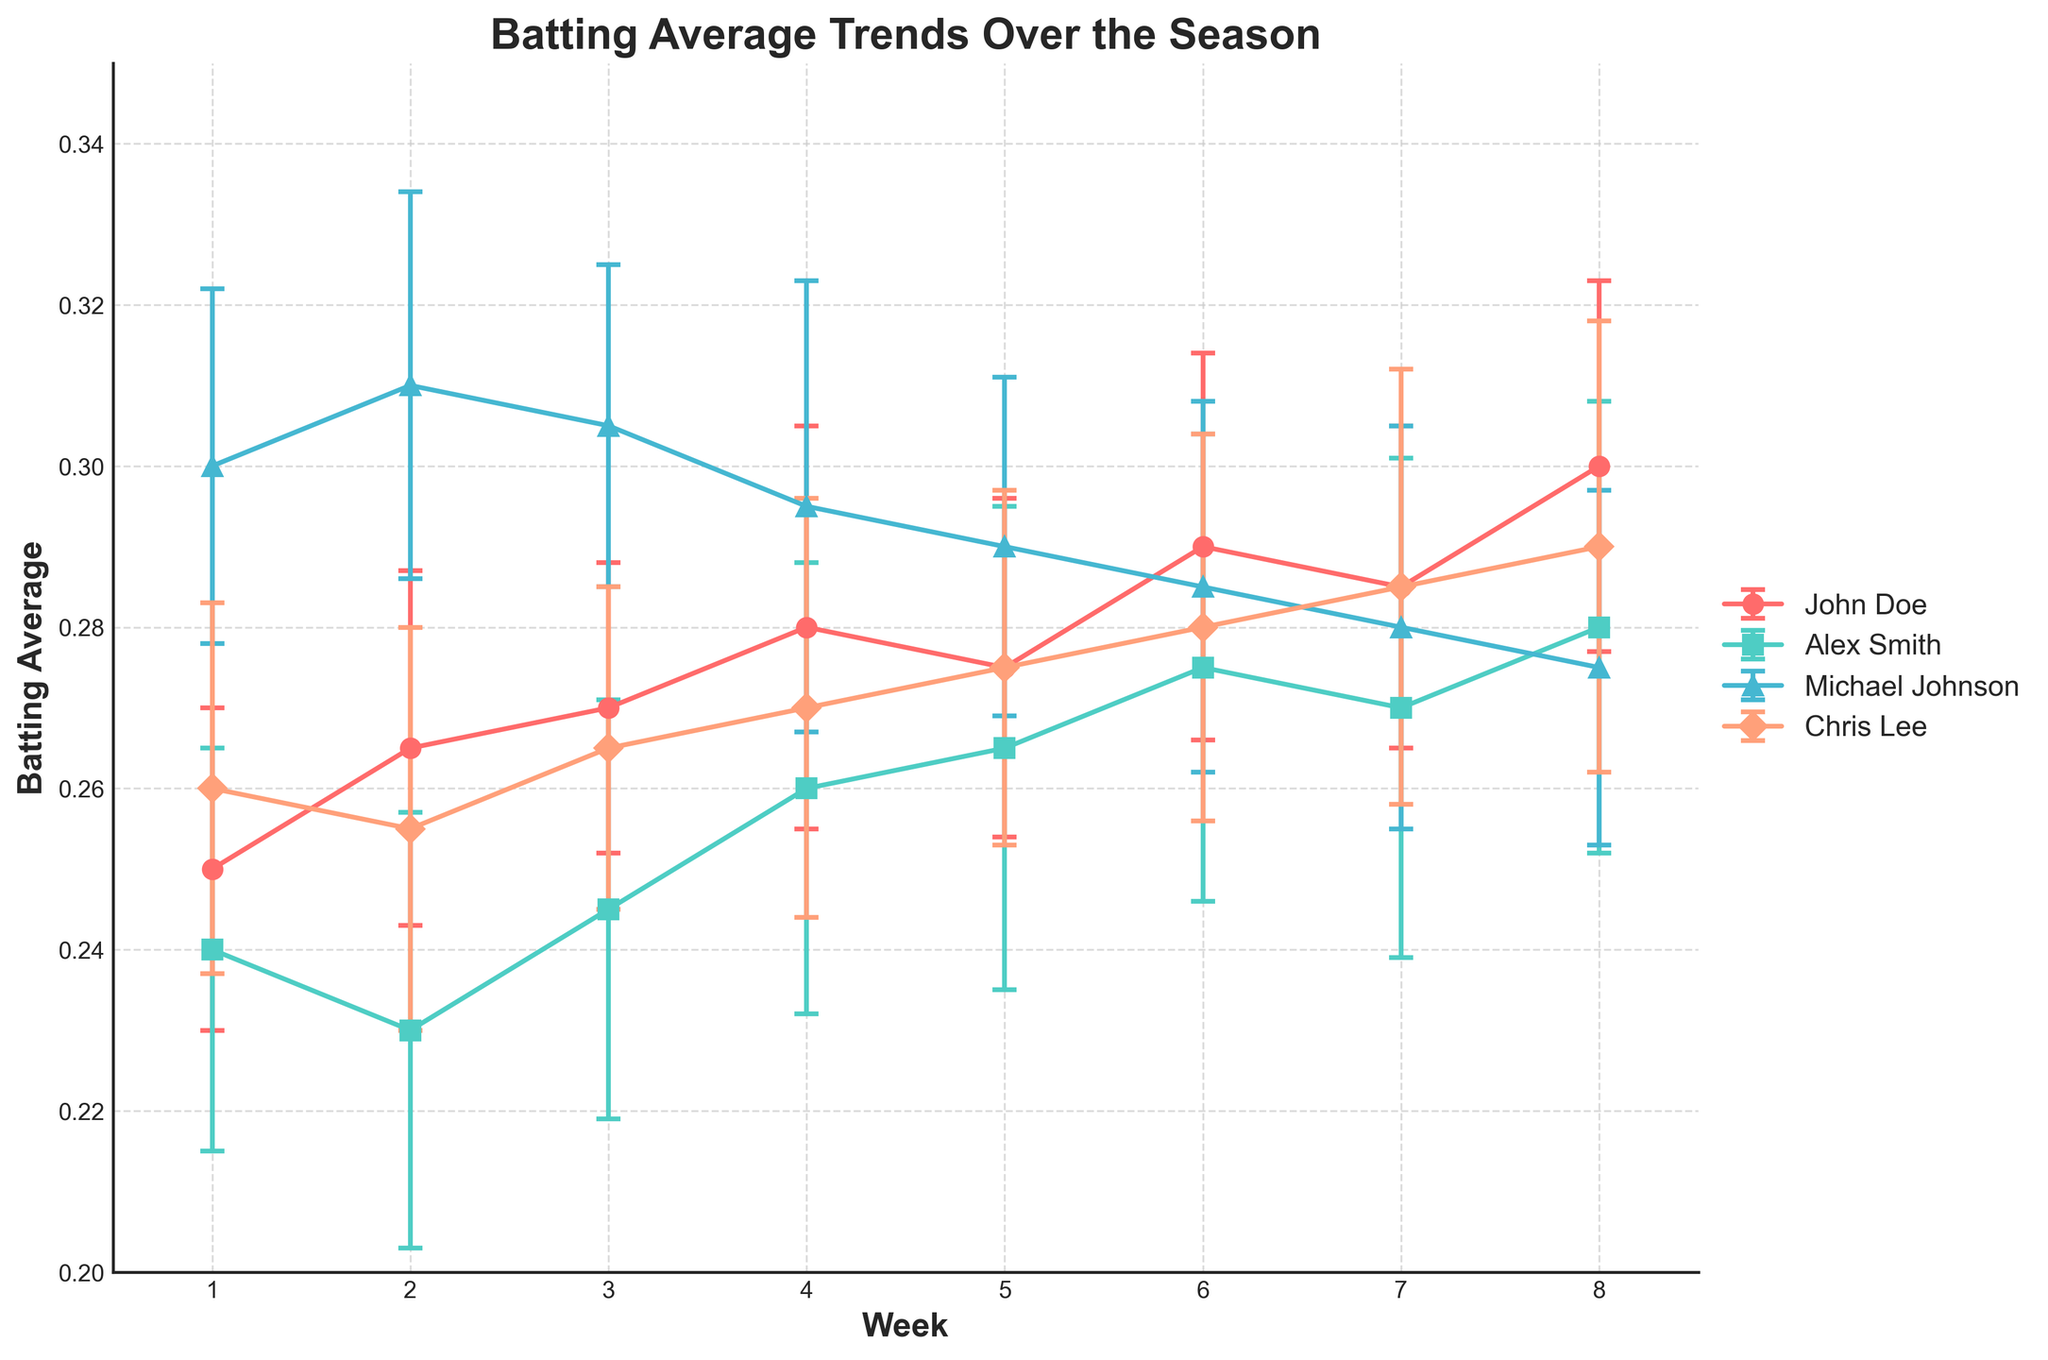What's the title of the plot? The title of the plot is displayed at the top center of the figure. It is visually distinguishable and provides a summary of what the plot is showing.
Answer: Batting Average Trends Over the Season What is the batting average of John Doe in Week 5? To find John Doe's batting average for Week 5, locate John Doe's line on the plot and then find the value corresponding to Week 5 on the x-axis. Refer to the y-axis for the corresponding batting average.
Answer: 0.275 Which player has the highest batting average in Week 8? To determine which player has the highest batting average in Week 8, look at the values for Week 8 along the x-axis for each player and compare the corresponding batting averages on the y-axis.
Answer: John Doe What is the general trend of Alex Smith's batting average over the season? To identify the general trend for Alex Smith, follow his line plot from Week 1 to Week 8. Observe the overall direction whether it is increasing, decreasing, or fluctuating.
Answer: Increasing How much did Michael Johnson's batting average decrease from Week 2 to Week 8? Determine Michael Johnson's batting average at Week 2 and Week 8 from the plot. Subtract the Week 8 average from the Week 2 average to find the decrease.
Answer: 0.035 Compare the variability in batting averages for Chris Lee and Alex Smith in Week 6. Which player has more variability and by how much? Examine the error bars for both Chris Lee and Alex Smith in Week 6 and measure their lengths. The longer the error bar, the higher the variability. Compare the lengths to find the one with more variability and calculate the difference.
Answer: Alex Smith by 0.005 On which week did Chris Lee and Michael Johnson have the same batting average? Track both Chris Lee's and Michael Johnson's lines and identify any week where their lines intersect, indicating the same batting average.
Answer: Week 6 What is the average batting average for John Doe over the season? Sum up John Doe's batting averages from Week 1 to Week 8 and divide by the number of weeks (8) to find the average.
Answer: 0.269 Who has the most consistent (least variable) batting average over the season according to the error bars? To determine the most consistent player, compare the lengths of the error bars for each player across all weeks. The player with the shortest overall error bars shows the least variability.
Answer: John Doe 